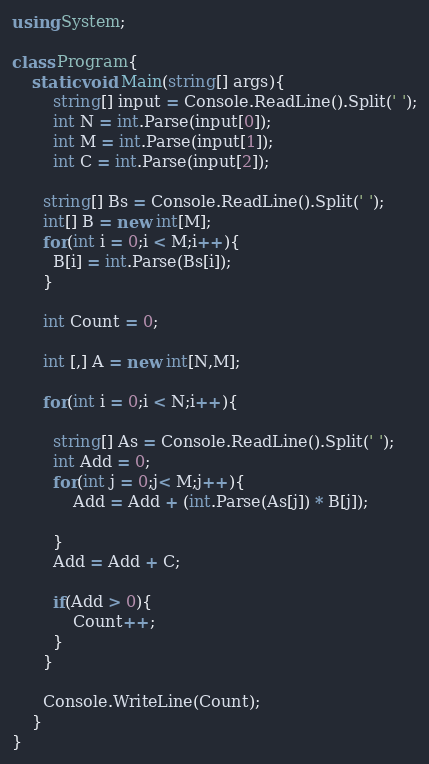<code> <loc_0><loc_0><loc_500><loc_500><_C#_>using System;

class Program{
	static void Main(string[] args){
    	string[] input = Console.ReadLine().Split(' ');
      	int N = int.Parse(input[0]);
        int M = int.Parse(input[1]);
        int C = int.Parse(input[2]);
      
      string[] Bs = Console.ReadLine().Split(' ');
      int[] B = new int[M];
      for(int i = 0;i < M;i++){
      	B[i] = int.Parse(Bs[i]);
      }
      
      int Count = 0;
      
      int [,] A = new int[N,M];
      
      for(int i = 0;i < N;i++){
        
        string[] As = Console.ReadLine().Split(' ');
        int Add = 0;
      	for(int j = 0;j< M;j++){
        	Add = Add + (int.Parse(As[j]) * B[j]);
        	
        }
        Add = Add + C;
        
        if(Add > 0){
        	Count++;
        }
      }
      
      Console.WriteLine(Count);
    }
}</code> 